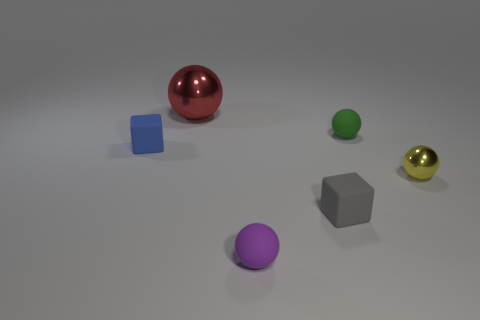Subtract all tiny yellow spheres. How many spheres are left? 3 Subtract all purple balls. How many balls are left? 3 Subtract all spheres. How many objects are left? 2 Add 2 large red shiny blocks. How many objects exist? 8 Subtract 1 yellow spheres. How many objects are left? 5 Subtract 1 cubes. How many cubes are left? 1 Subtract all red balls. Subtract all blue cylinders. How many balls are left? 3 Subtract all green cylinders. How many blue cubes are left? 1 Subtract all big red matte spheres. Subtract all blue things. How many objects are left? 5 Add 4 small metallic things. How many small metallic things are left? 5 